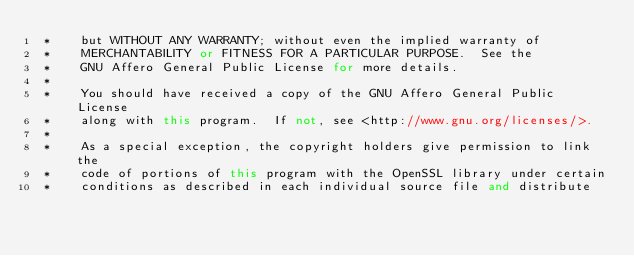<code> <loc_0><loc_0><loc_500><loc_500><_C++_> *    but WITHOUT ANY WARRANTY; without even the implied warranty of
 *    MERCHANTABILITY or FITNESS FOR A PARTICULAR PURPOSE.  See the
 *    GNU Affero General Public License for more details.
 *
 *    You should have received a copy of the GNU Affero General Public License
 *    along with this program.  If not, see <http://www.gnu.org/licenses/>.
 *
 *    As a special exception, the copyright holders give permission to link the
 *    code of portions of this program with the OpenSSL library under certain
 *    conditions as described in each individual source file and distribute</code> 